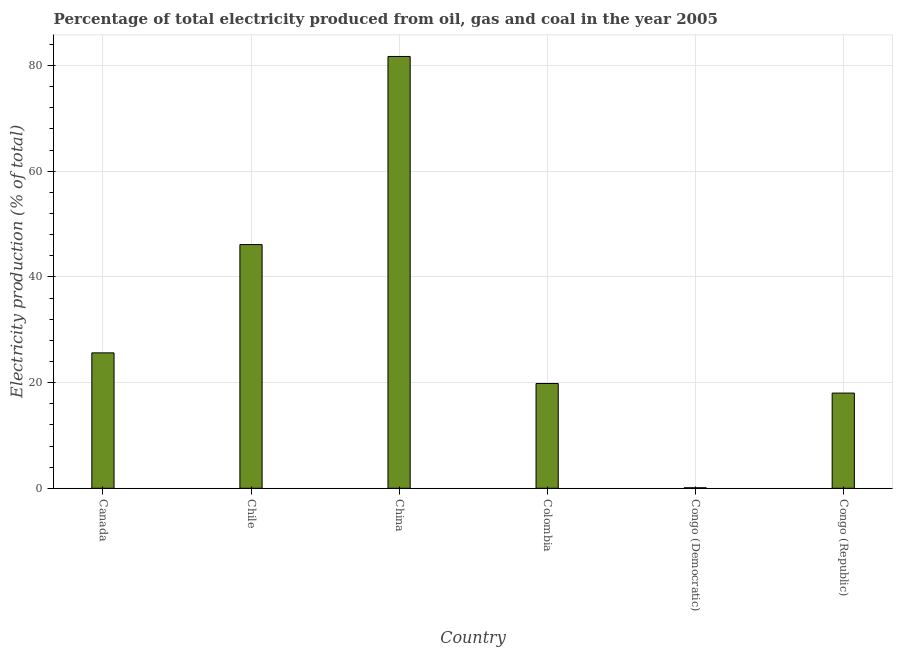What is the title of the graph?
Your answer should be very brief. Percentage of total electricity produced from oil, gas and coal in the year 2005. What is the label or title of the X-axis?
Your answer should be very brief. Country. What is the label or title of the Y-axis?
Give a very brief answer. Electricity production (% of total). What is the electricity production in China?
Offer a very short reply. 81.72. Across all countries, what is the maximum electricity production?
Give a very brief answer. 81.72. Across all countries, what is the minimum electricity production?
Give a very brief answer. 0.09. In which country was the electricity production minimum?
Ensure brevity in your answer.  Congo (Democratic). What is the sum of the electricity production?
Give a very brief answer. 191.4. What is the difference between the electricity production in Canada and Congo (Republic)?
Make the answer very short. 7.61. What is the average electricity production per country?
Your answer should be very brief. 31.9. What is the median electricity production?
Your answer should be very brief. 22.73. What is the ratio of the electricity production in Canada to that in Congo (Democratic)?
Offer a very short reply. 270.9. Is the electricity production in Canada less than that in Congo (Democratic)?
Ensure brevity in your answer.  No. What is the difference between the highest and the second highest electricity production?
Make the answer very short. 35.6. What is the difference between the highest and the lowest electricity production?
Offer a very short reply. 81.62. Are all the bars in the graph horizontal?
Provide a succinct answer. No. What is the difference between two consecutive major ticks on the Y-axis?
Offer a terse response. 20. What is the Electricity production (% of total) of Canada?
Ensure brevity in your answer.  25.63. What is the Electricity production (% of total) of Chile?
Provide a short and direct response. 46.12. What is the Electricity production (% of total) in China?
Offer a terse response. 81.72. What is the Electricity production (% of total) of Colombia?
Give a very brief answer. 19.83. What is the Electricity production (% of total) of Congo (Democratic)?
Keep it short and to the point. 0.09. What is the Electricity production (% of total) in Congo (Republic)?
Ensure brevity in your answer.  18.01. What is the difference between the Electricity production (% of total) in Canada and Chile?
Your answer should be compact. -20.49. What is the difference between the Electricity production (% of total) in Canada and China?
Your response must be concise. -56.09. What is the difference between the Electricity production (% of total) in Canada and Colombia?
Offer a very short reply. 5.8. What is the difference between the Electricity production (% of total) in Canada and Congo (Democratic)?
Ensure brevity in your answer.  25.53. What is the difference between the Electricity production (% of total) in Canada and Congo (Republic)?
Your answer should be very brief. 7.61. What is the difference between the Electricity production (% of total) in Chile and China?
Offer a very short reply. -35.6. What is the difference between the Electricity production (% of total) in Chile and Colombia?
Make the answer very short. 26.29. What is the difference between the Electricity production (% of total) in Chile and Congo (Democratic)?
Your answer should be compact. 46.02. What is the difference between the Electricity production (% of total) in Chile and Congo (Republic)?
Provide a short and direct response. 28.1. What is the difference between the Electricity production (% of total) in China and Colombia?
Your response must be concise. 61.89. What is the difference between the Electricity production (% of total) in China and Congo (Democratic)?
Give a very brief answer. 81.62. What is the difference between the Electricity production (% of total) in China and Congo (Republic)?
Your answer should be very brief. 63.7. What is the difference between the Electricity production (% of total) in Colombia and Congo (Democratic)?
Your answer should be compact. 19.74. What is the difference between the Electricity production (% of total) in Colombia and Congo (Republic)?
Ensure brevity in your answer.  1.82. What is the difference between the Electricity production (% of total) in Congo (Democratic) and Congo (Republic)?
Ensure brevity in your answer.  -17.92. What is the ratio of the Electricity production (% of total) in Canada to that in Chile?
Provide a short and direct response. 0.56. What is the ratio of the Electricity production (% of total) in Canada to that in China?
Make the answer very short. 0.31. What is the ratio of the Electricity production (% of total) in Canada to that in Colombia?
Ensure brevity in your answer.  1.29. What is the ratio of the Electricity production (% of total) in Canada to that in Congo (Democratic)?
Provide a succinct answer. 270.9. What is the ratio of the Electricity production (% of total) in Canada to that in Congo (Republic)?
Make the answer very short. 1.42. What is the ratio of the Electricity production (% of total) in Chile to that in China?
Provide a succinct answer. 0.56. What is the ratio of the Electricity production (% of total) in Chile to that in Colombia?
Your answer should be very brief. 2.33. What is the ratio of the Electricity production (% of total) in Chile to that in Congo (Democratic)?
Ensure brevity in your answer.  487.52. What is the ratio of the Electricity production (% of total) in Chile to that in Congo (Republic)?
Offer a terse response. 2.56. What is the ratio of the Electricity production (% of total) in China to that in Colombia?
Keep it short and to the point. 4.12. What is the ratio of the Electricity production (% of total) in China to that in Congo (Democratic)?
Ensure brevity in your answer.  863.86. What is the ratio of the Electricity production (% of total) in China to that in Congo (Republic)?
Your response must be concise. 4.54. What is the ratio of the Electricity production (% of total) in Colombia to that in Congo (Democratic)?
Ensure brevity in your answer.  209.63. What is the ratio of the Electricity production (% of total) in Colombia to that in Congo (Republic)?
Keep it short and to the point. 1.1. What is the ratio of the Electricity production (% of total) in Congo (Democratic) to that in Congo (Republic)?
Keep it short and to the point. 0.01. 